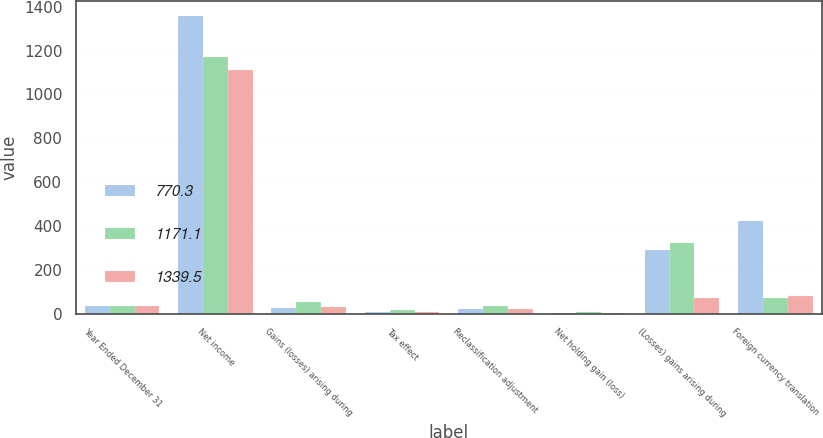Convert chart to OTSL. <chart><loc_0><loc_0><loc_500><loc_500><stacked_bar_chart><ecel><fcel>Year Ended December 31<fcel>Net income<fcel>Gains (losses) arising during<fcel>Tax effect<fcel>Reclassification adjustment<fcel>Net holding gain (loss)<fcel>(Losses) gains arising during<fcel>Foreign currency translation<nl><fcel>770.3<fcel>35.6<fcel>1358.8<fcel>26.1<fcel>6.1<fcel>23.5<fcel>5.5<fcel>291.1<fcel>422.8<nl><fcel>1171.1<fcel>35.6<fcel>1171.3<fcel>53.2<fcel>16.3<fcel>35.6<fcel>8.3<fcel>324.9<fcel>73.3<nl><fcel>1339.5<fcel>35.6<fcel>1111.6<fcel>29.2<fcel>9.1<fcel>22.7<fcel>2.7<fcel>71<fcel>83.1<nl></chart> 